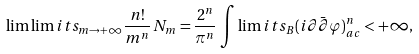Convert formula to latex. <formula><loc_0><loc_0><loc_500><loc_500>\lim \lim i t s _ { m \rightarrow + \infty } \frac { n ! } { m ^ { n } } \, N _ { m } = \frac { 2 ^ { n } } { \pi ^ { n } } \, \int \lim i t s _ { B } ( i \partial \bar { \partial } \varphi ) ^ { n } _ { a c } < + \infty ,</formula> 